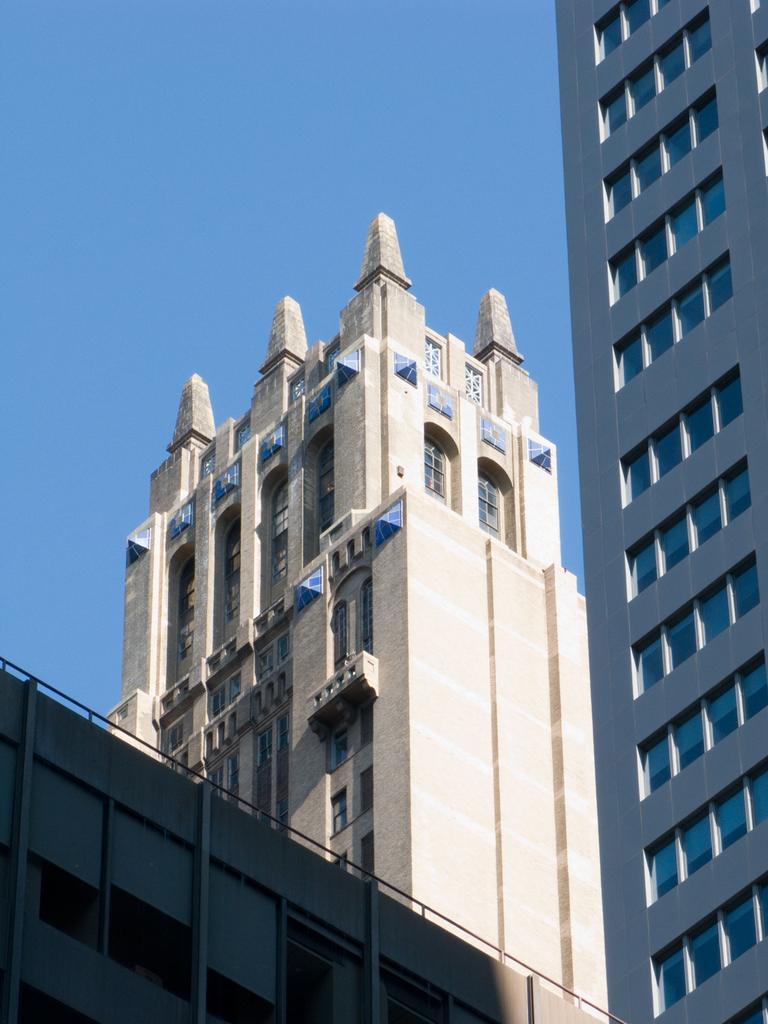Could you give a brief overview of what you see in this image? In this picture I can see there are few buildings and it has few windows, which is made of glass. The sky is clear. 